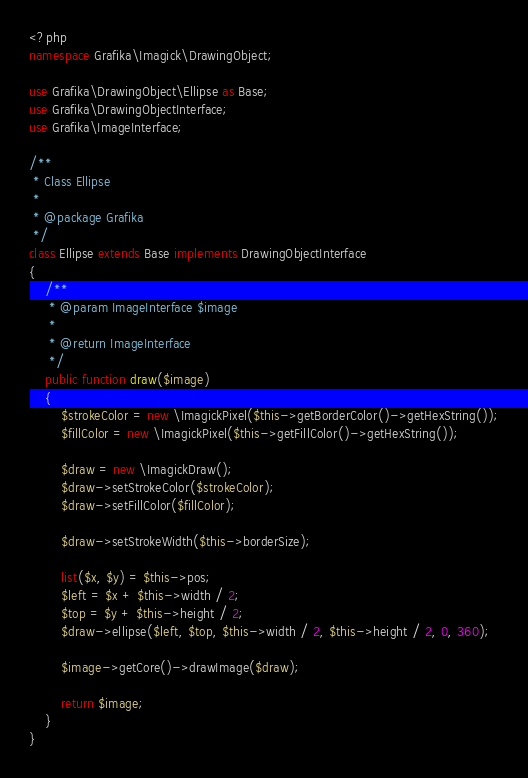<code> <loc_0><loc_0><loc_500><loc_500><_PHP_><?php
namespace Grafika\Imagick\DrawingObject;

use Grafika\DrawingObject\Ellipse as Base;
use Grafika\DrawingObjectInterface;
use Grafika\ImageInterface;

/**
 * Class Ellipse
 *
 * @package Grafika
 */
class Ellipse extends Base implements DrawingObjectInterface
{
    /**
     * @param ImageInterface $image
     *
     * @return ImageInterface
     */
    public function draw($image)
    {
        $strokeColor = new \ImagickPixel($this->getBorderColor()->getHexString());
        $fillColor = new \ImagickPixel($this->getFillColor()->getHexString());

        $draw = new \ImagickDraw();
        $draw->setStrokeColor($strokeColor);
        $draw->setFillColor($fillColor);

        $draw->setStrokeWidth($this->borderSize);

        list($x, $y) = $this->pos;
        $left = $x + $this->width / 2;
        $top = $y + $this->height / 2;
        $draw->ellipse($left, $top, $this->width / 2, $this->height / 2, 0, 360);

        $image->getCore()->drawImage($draw);

        return $image;
    }
}
</code> 